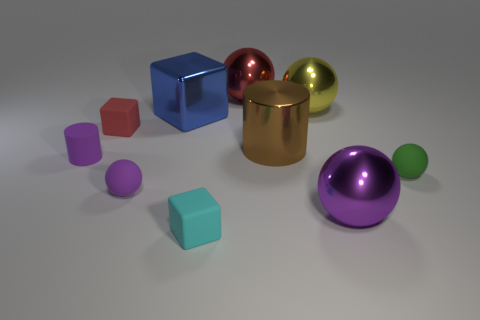How many small rubber balls are there?
Ensure brevity in your answer.  2. Are there any other things that are the same size as the yellow shiny object?
Your response must be concise. Yes. Is the material of the large brown cylinder the same as the tiny red block?
Ensure brevity in your answer.  No. Is the size of the red thing that is to the right of the tiny red object the same as the purple sphere to the right of the big cube?
Your response must be concise. Yes. Are there fewer purple rubber balls than small green shiny things?
Offer a terse response. No. What number of rubber objects are small blocks or tiny things?
Offer a very short reply. 5. Are there any things that are to the left of the big shiny object on the right side of the yellow metallic object?
Make the answer very short. Yes. Do the tiny purple object that is on the left side of the tiny red cube and the red cube have the same material?
Provide a succinct answer. Yes. What number of other things are there of the same color as the big metallic cylinder?
Make the answer very short. 0. There is a matte thing that is to the left of the matte cube behind the green matte thing; what size is it?
Your answer should be very brief. Small. 